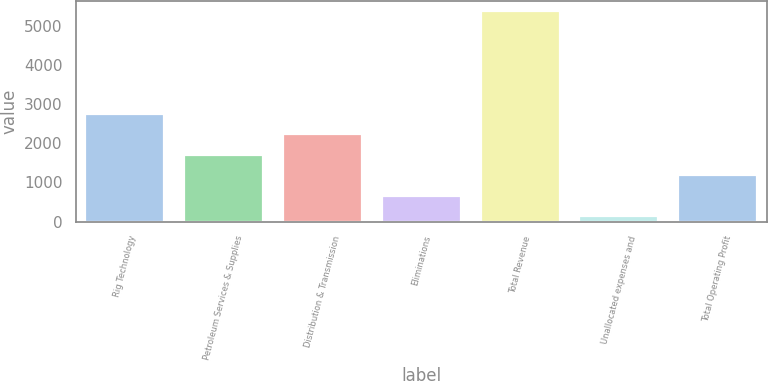<chart> <loc_0><loc_0><loc_500><loc_500><bar_chart><fcel>Rig Technology<fcel>Petroleum Services & Supplies<fcel>Distribution & Transmission<fcel>Eliminations<fcel>Total Revenue<fcel>Unallocated expenses and<fcel>Total Operating Profit<nl><fcel>2762<fcel>1713.6<fcel>2237.8<fcel>665.2<fcel>5383<fcel>141<fcel>1189.4<nl></chart> 